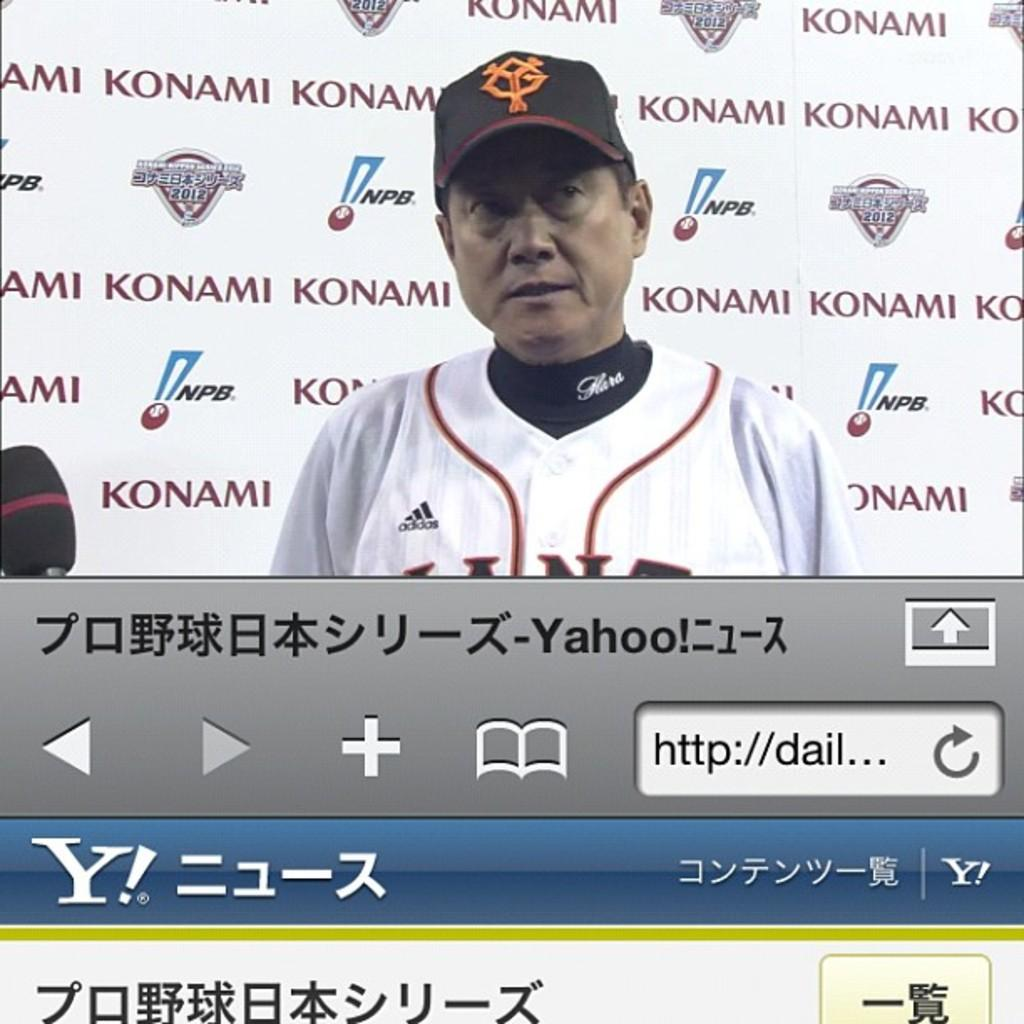<image>
Offer a succinct explanation of the picture presented. A Japanese baseball player is shown on Yahoo's website. 